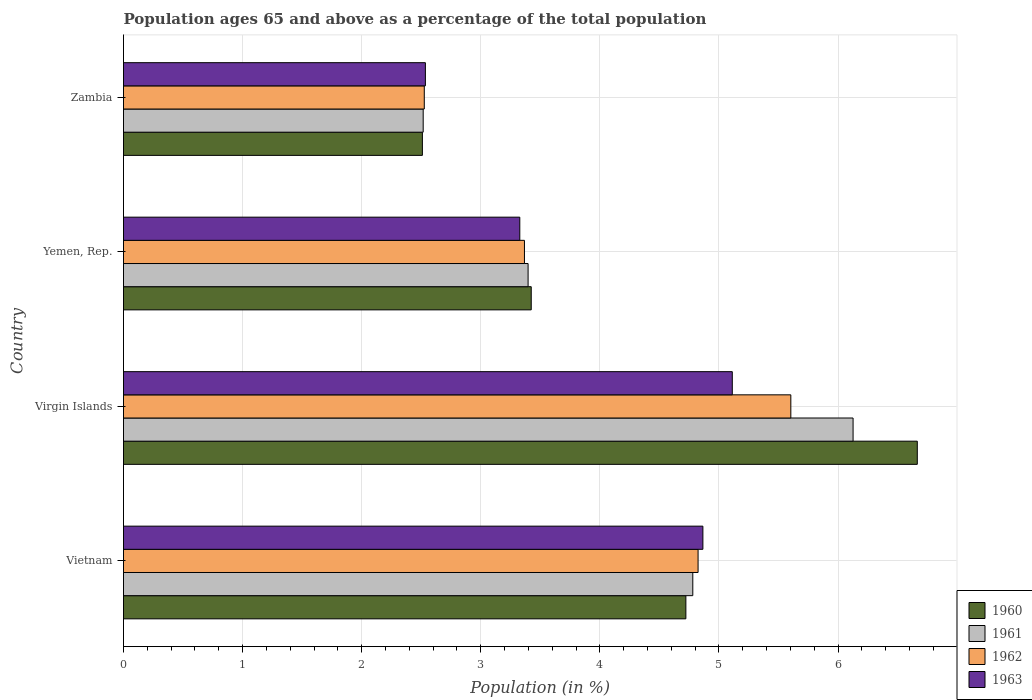How many different coloured bars are there?
Offer a very short reply. 4. Are the number of bars per tick equal to the number of legend labels?
Your answer should be compact. Yes. Are the number of bars on each tick of the Y-axis equal?
Ensure brevity in your answer.  Yes. How many bars are there on the 4th tick from the top?
Provide a short and direct response. 4. How many bars are there on the 1st tick from the bottom?
Your answer should be very brief. 4. What is the label of the 3rd group of bars from the top?
Provide a succinct answer. Virgin Islands. In how many cases, is the number of bars for a given country not equal to the number of legend labels?
Keep it short and to the point. 0. What is the percentage of the population ages 65 and above in 1961 in Virgin Islands?
Your answer should be compact. 6.13. Across all countries, what is the maximum percentage of the population ages 65 and above in 1962?
Offer a very short reply. 5.6. Across all countries, what is the minimum percentage of the population ages 65 and above in 1961?
Keep it short and to the point. 2.52. In which country was the percentage of the population ages 65 and above in 1961 maximum?
Offer a very short reply. Virgin Islands. In which country was the percentage of the population ages 65 and above in 1961 minimum?
Give a very brief answer. Zambia. What is the total percentage of the population ages 65 and above in 1961 in the graph?
Provide a short and direct response. 16.82. What is the difference between the percentage of the population ages 65 and above in 1962 in Vietnam and that in Virgin Islands?
Offer a terse response. -0.78. What is the difference between the percentage of the population ages 65 and above in 1962 in Yemen, Rep. and the percentage of the population ages 65 and above in 1961 in Vietnam?
Offer a very short reply. -1.41. What is the average percentage of the population ages 65 and above in 1960 per country?
Your response must be concise. 4.33. What is the difference between the percentage of the population ages 65 and above in 1963 and percentage of the population ages 65 and above in 1961 in Vietnam?
Keep it short and to the point. 0.08. In how many countries, is the percentage of the population ages 65 and above in 1961 greater than 1.8 ?
Keep it short and to the point. 4. What is the ratio of the percentage of the population ages 65 and above in 1960 in Virgin Islands to that in Zambia?
Give a very brief answer. 2.66. Is the percentage of the population ages 65 and above in 1960 in Virgin Islands less than that in Zambia?
Provide a succinct answer. No. Is the difference between the percentage of the population ages 65 and above in 1963 in Virgin Islands and Yemen, Rep. greater than the difference between the percentage of the population ages 65 and above in 1961 in Virgin Islands and Yemen, Rep.?
Offer a very short reply. No. What is the difference between the highest and the second highest percentage of the population ages 65 and above in 1960?
Provide a succinct answer. 1.94. What is the difference between the highest and the lowest percentage of the population ages 65 and above in 1960?
Give a very brief answer. 4.16. In how many countries, is the percentage of the population ages 65 and above in 1960 greater than the average percentage of the population ages 65 and above in 1960 taken over all countries?
Provide a succinct answer. 2. What does the 2nd bar from the top in Zambia represents?
Offer a terse response. 1962. What does the 2nd bar from the bottom in Yemen, Rep. represents?
Your answer should be compact. 1961. How many countries are there in the graph?
Your answer should be compact. 4. What is the difference between two consecutive major ticks on the X-axis?
Your answer should be compact. 1. Are the values on the major ticks of X-axis written in scientific E-notation?
Your response must be concise. No. Where does the legend appear in the graph?
Make the answer very short. Bottom right. How many legend labels are there?
Ensure brevity in your answer.  4. What is the title of the graph?
Offer a terse response. Population ages 65 and above as a percentage of the total population. Does "1967" appear as one of the legend labels in the graph?
Offer a terse response. No. What is the label or title of the X-axis?
Make the answer very short. Population (in %). What is the Population (in %) of 1960 in Vietnam?
Offer a terse response. 4.72. What is the Population (in %) in 1961 in Vietnam?
Your answer should be very brief. 4.78. What is the Population (in %) in 1962 in Vietnam?
Provide a succinct answer. 4.82. What is the Population (in %) in 1963 in Vietnam?
Give a very brief answer. 4.86. What is the Population (in %) of 1960 in Virgin Islands?
Offer a very short reply. 6.67. What is the Population (in %) in 1961 in Virgin Islands?
Give a very brief answer. 6.13. What is the Population (in %) of 1962 in Virgin Islands?
Provide a succinct answer. 5.6. What is the Population (in %) of 1963 in Virgin Islands?
Your answer should be very brief. 5.11. What is the Population (in %) of 1960 in Yemen, Rep.?
Provide a short and direct response. 3.42. What is the Population (in %) of 1961 in Yemen, Rep.?
Ensure brevity in your answer.  3.4. What is the Population (in %) in 1962 in Yemen, Rep.?
Provide a short and direct response. 3.37. What is the Population (in %) of 1963 in Yemen, Rep.?
Your answer should be compact. 3.33. What is the Population (in %) in 1960 in Zambia?
Your answer should be compact. 2.51. What is the Population (in %) in 1961 in Zambia?
Keep it short and to the point. 2.52. What is the Population (in %) in 1962 in Zambia?
Your response must be concise. 2.53. What is the Population (in %) of 1963 in Zambia?
Your answer should be very brief. 2.53. Across all countries, what is the maximum Population (in %) in 1960?
Offer a very short reply. 6.67. Across all countries, what is the maximum Population (in %) in 1961?
Keep it short and to the point. 6.13. Across all countries, what is the maximum Population (in %) of 1962?
Provide a succinct answer. 5.6. Across all countries, what is the maximum Population (in %) in 1963?
Your answer should be compact. 5.11. Across all countries, what is the minimum Population (in %) in 1960?
Your answer should be compact. 2.51. Across all countries, what is the minimum Population (in %) of 1961?
Your response must be concise. 2.52. Across all countries, what is the minimum Population (in %) of 1962?
Offer a terse response. 2.53. Across all countries, what is the minimum Population (in %) of 1963?
Offer a terse response. 2.53. What is the total Population (in %) in 1960 in the graph?
Your answer should be compact. 17.32. What is the total Population (in %) of 1961 in the graph?
Your answer should be very brief. 16.82. What is the total Population (in %) of 1962 in the graph?
Offer a terse response. 16.32. What is the total Population (in %) in 1963 in the graph?
Keep it short and to the point. 15.84. What is the difference between the Population (in %) in 1960 in Vietnam and that in Virgin Islands?
Offer a very short reply. -1.94. What is the difference between the Population (in %) of 1961 in Vietnam and that in Virgin Islands?
Your answer should be compact. -1.35. What is the difference between the Population (in %) of 1962 in Vietnam and that in Virgin Islands?
Ensure brevity in your answer.  -0.78. What is the difference between the Population (in %) in 1963 in Vietnam and that in Virgin Islands?
Provide a succinct answer. -0.25. What is the difference between the Population (in %) of 1960 in Vietnam and that in Yemen, Rep.?
Provide a succinct answer. 1.3. What is the difference between the Population (in %) of 1961 in Vietnam and that in Yemen, Rep.?
Make the answer very short. 1.38. What is the difference between the Population (in %) in 1962 in Vietnam and that in Yemen, Rep.?
Your answer should be compact. 1.46. What is the difference between the Population (in %) of 1963 in Vietnam and that in Yemen, Rep.?
Your response must be concise. 1.54. What is the difference between the Population (in %) in 1960 in Vietnam and that in Zambia?
Give a very brief answer. 2.21. What is the difference between the Population (in %) of 1961 in Vietnam and that in Zambia?
Provide a succinct answer. 2.26. What is the difference between the Population (in %) of 1962 in Vietnam and that in Zambia?
Offer a very short reply. 2.3. What is the difference between the Population (in %) in 1963 in Vietnam and that in Zambia?
Offer a very short reply. 2.33. What is the difference between the Population (in %) of 1960 in Virgin Islands and that in Yemen, Rep.?
Make the answer very short. 3.24. What is the difference between the Population (in %) of 1961 in Virgin Islands and that in Yemen, Rep.?
Your answer should be compact. 2.73. What is the difference between the Population (in %) in 1962 in Virgin Islands and that in Yemen, Rep.?
Your response must be concise. 2.24. What is the difference between the Population (in %) in 1963 in Virgin Islands and that in Yemen, Rep.?
Your response must be concise. 1.78. What is the difference between the Population (in %) in 1960 in Virgin Islands and that in Zambia?
Keep it short and to the point. 4.16. What is the difference between the Population (in %) in 1961 in Virgin Islands and that in Zambia?
Offer a terse response. 3.61. What is the difference between the Population (in %) in 1962 in Virgin Islands and that in Zambia?
Your answer should be very brief. 3.08. What is the difference between the Population (in %) of 1963 in Virgin Islands and that in Zambia?
Provide a succinct answer. 2.58. What is the difference between the Population (in %) in 1960 in Yemen, Rep. and that in Zambia?
Make the answer very short. 0.91. What is the difference between the Population (in %) in 1961 in Yemen, Rep. and that in Zambia?
Provide a short and direct response. 0.88. What is the difference between the Population (in %) of 1962 in Yemen, Rep. and that in Zambia?
Keep it short and to the point. 0.84. What is the difference between the Population (in %) in 1963 in Yemen, Rep. and that in Zambia?
Give a very brief answer. 0.79. What is the difference between the Population (in %) in 1960 in Vietnam and the Population (in %) in 1961 in Virgin Islands?
Offer a terse response. -1.4. What is the difference between the Population (in %) in 1960 in Vietnam and the Population (in %) in 1962 in Virgin Islands?
Ensure brevity in your answer.  -0.88. What is the difference between the Population (in %) of 1960 in Vietnam and the Population (in %) of 1963 in Virgin Islands?
Give a very brief answer. -0.39. What is the difference between the Population (in %) in 1961 in Vietnam and the Population (in %) in 1962 in Virgin Islands?
Offer a terse response. -0.82. What is the difference between the Population (in %) of 1961 in Vietnam and the Population (in %) of 1963 in Virgin Islands?
Offer a terse response. -0.33. What is the difference between the Population (in %) in 1962 in Vietnam and the Population (in %) in 1963 in Virgin Islands?
Keep it short and to the point. -0.29. What is the difference between the Population (in %) in 1960 in Vietnam and the Population (in %) in 1961 in Yemen, Rep.?
Your answer should be compact. 1.32. What is the difference between the Population (in %) of 1960 in Vietnam and the Population (in %) of 1962 in Yemen, Rep.?
Provide a succinct answer. 1.36. What is the difference between the Population (in %) in 1960 in Vietnam and the Population (in %) in 1963 in Yemen, Rep.?
Make the answer very short. 1.39. What is the difference between the Population (in %) of 1961 in Vietnam and the Population (in %) of 1962 in Yemen, Rep.?
Give a very brief answer. 1.41. What is the difference between the Population (in %) in 1961 in Vietnam and the Population (in %) in 1963 in Yemen, Rep.?
Keep it short and to the point. 1.45. What is the difference between the Population (in %) of 1962 in Vietnam and the Population (in %) of 1963 in Yemen, Rep.?
Offer a terse response. 1.5. What is the difference between the Population (in %) of 1960 in Vietnam and the Population (in %) of 1961 in Zambia?
Provide a succinct answer. 2.21. What is the difference between the Population (in %) in 1960 in Vietnam and the Population (in %) in 1962 in Zambia?
Give a very brief answer. 2.2. What is the difference between the Population (in %) in 1960 in Vietnam and the Population (in %) in 1963 in Zambia?
Your answer should be compact. 2.19. What is the difference between the Population (in %) in 1961 in Vietnam and the Population (in %) in 1962 in Zambia?
Offer a very short reply. 2.25. What is the difference between the Population (in %) in 1961 in Vietnam and the Population (in %) in 1963 in Zambia?
Make the answer very short. 2.25. What is the difference between the Population (in %) of 1962 in Vietnam and the Population (in %) of 1963 in Zambia?
Offer a very short reply. 2.29. What is the difference between the Population (in %) of 1960 in Virgin Islands and the Population (in %) of 1961 in Yemen, Rep.?
Make the answer very short. 3.27. What is the difference between the Population (in %) in 1960 in Virgin Islands and the Population (in %) in 1962 in Yemen, Rep.?
Your response must be concise. 3.3. What is the difference between the Population (in %) of 1960 in Virgin Islands and the Population (in %) of 1963 in Yemen, Rep.?
Offer a very short reply. 3.34. What is the difference between the Population (in %) of 1961 in Virgin Islands and the Population (in %) of 1962 in Yemen, Rep.?
Offer a very short reply. 2.76. What is the difference between the Population (in %) in 1961 in Virgin Islands and the Population (in %) in 1963 in Yemen, Rep.?
Provide a succinct answer. 2.8. What is the difference between the Population (in %) of 1962 in Virgin Islands and the Population (in %) of 1963 in Yemen, Rep.?
Give a very brief answer. 2.28. What is the difference between the Population (in %) in 1960 in Virgin Islands and the Population (in %) in 1961 in Zambia?
Your response must be concise. 4.15. What is the difference between the Population (in %) of 1960 in Virgin Islands and the Population (in %) of 1962 in Zambia?
Your response must be concise. 4.14. What is the difference between the Population (in %) of 1960 in Virgin Islands and the Population (in %) of 1963 in Zambia?
Your answer should be compact. 4.13. What is the difference between the Population (in %) of 1961 in Virgin Islands and the Population (in %) of 1962 in Zambia?
Provide a succinct answer. 3.6. What is the difference between the Population (in %) in 1961 in Virgin Islands and the Population (in %) in 1963 in Zambia?
Make the answer very short. 3.59. What is the difference between the Population (in %) in 1962 in Virgin Islands and the Population (in %) in 1963 in Zambia?
Make the answer very short. 3.07. What is the difference between the Population (in %) of 1960 in Yemen, Rep. and the Population (in %) of 1961 in Zambia?
Offer a very short reply. 0.91. What is the difference between the Population (in %) of 1960 in Yemen, Rep. and the Population (in %) of 1962 in Zambia?
Give a very brief answer. 0.9. What is the difference between the Population (in %) in 1960 in Yemen, Rep. and the Population (in %) in 1963 in Zambia?
Give a very brief answer. 0.89. What is the difference between the Population (in %) in 1961 in Yemen, Rep. and the Population (in %) in 1962 in Zambia?
Provide a succinct answer. 0.87. What is the difference between the Population (in %) of 1961 in Yemen, Rep. and the Population (in %) of 1963 in Zambia?
Provide a short and direct response. 0.86. What is the difference between the Population (in %) in 1962 in Yemen, Rep. and the Population (in %) in 1963 in Zambia?
Offer a very short reply. 0.83. What is the average Population (in %) in 1960 per country?
Give a very brief answer. 4.33. What is the average Population (in %) in 1961 per country?
Your answer should be compact. 4.2. What is the average Population (in %) of 1962 per country?
Ensure brevity in your answer.  4.08. What is the average Population (in %) of 1963 per country?
Offer a very short reply. 3.96. What is the difference between the Population (in %) in 1960 and Population (in %) in 1961 in Vietnam?
Provide a short and direct response. -0.06. What is the difference between the Population (in %) in 1960 and Population (in %) in 1962 in Vietnam?
Your answer should be very brief. -0.1. What is the difference between the Population (in %) in 1960 and Population (in %) in 1963 in Vietnam?
Make the answer very short. -0.14. What is the difference between the Population (in %) of 1961 and Population (in %) of 1962 in Vietnam?
Give a very brief answer. -0.04. What is the difference between the Population (in %) in 1961 and Population (in %) in 1963 in Vietnam?
Provide a short and direct response. -0.08. What is the difference between the Population (in %) of 1962 and Population (in %) of 1963 in Vietnam?
Your response must be concise. -0.04. What is the difference between the Population (in %) of 1960 and Population (in %) of 1961 in Virgin Islands?
Your response must be concise. 0.54. What is the difference between the Population (in %) of 1960 and Population (in %) of 1962 in Virgin Islands?
Give a very brief answer. 1.06. What is the difference between the Population (in %) in 1960 and Population (in %) in 1963 in Virgin Islands?
Offer a very short reply. 1.55. What is the difference between the Population (in %) in 1961 and Population (in %) in 1962 in Virgin Islands?
Ensure brevity in your answer.  0.52. What is the difference between the Population (in %) of 1961 and Population (in %) of 1963 in Virgin Islands?
Your answer should be compact. 1.01. What is the difference between the Population (in %) in 1962 and Population (in %) in 1963 in Virgin Islands?
Your answer should be very brief. 0.49. What is the difference between the Population (in %) in 1960 and Population (in %) in 1961 in Yemen, Rep.?
Keep it short and to the point. 0.03. What is the difference between the Population (in %) of 1960 and Population (in %) of 1962 in Yemen, Rep.?
Offer a very short reply. 0.06. What is the difference between the Population (in %) of 1960 and Population (in %) of 1963 in Yemen, Rep.?
Provide a short and direct response. 0.1. What is the difference between the Population (in %) of 1961 and Population (in %) of 1962 in Yemen, Rep.?
Make the answer very short. 0.03. What is the difference between the Population (in %) of 1961 and Population (in %) of 1963 in Yemen, Rep.?
Provide a succinct answer. 0.07. What is the difference between the Population (in %) of 1962 and Population (in %) of 1963 in Yemen, Rep.?
Give a very brief answer. 0.04. What is the difference between the Population (in %) in 1960 and Population (in %) in 1961 in Zambia?
Your answer should be compact. -0.01. What is the difference between the Population (in %) in 1960 and Population (in %) in 1962 in Zambia?
Ensure brevity in your answer.  -0.02. What is the difference between the Population (in %) in 1960 and Population (in %) in 1963 in Zambia?
Provide a succinct answer. -0.03. What is the difference between the Population (in %) in 1961 and Population (in %) in 1962 in Zambia?
Keep it short and to the point. -0.01. What is the difference between the Population (in %) of 1961 and Population (in %) of 1963 in Zambia?
Give a very brief answer. -0.02. What is the difference between the Population (in %) in 1962 and Population (in %) in 1963 in Zambia?
Give a very brief answer. -0.01. What is the ratio of the Population (in %) of 1960 in Vietnam to that in Virgin Islands?
Your response must be concise. 0.71. What is the ratio of the Population (in %) of 1961 in Vietnam to that in Virgin Islands?
Offer a terse response. 0.78. What is the ratio of the Population (in %) of 1962 in Vietnam to that in Virgin Islands?
Make the answer very short. 0.86. What is the ratio of the Population (in %) in 1963 in Vietnam to that in Virgin Islands?
Ensure brevity in your answer.  0.95. What is the ratio of the Population (in %) in 1960 in Vietnam to that in Yemen, Rep.?
Your response must be concise. 1.38. What is the ratio of the Population (in %) in 1961 in Vietnam to that in Yemen, Rep.?
Provide a succinct answer. 1.41. What is the ratio of the Population (in %) in 1962 in Vietnam to that in Yemen, Rep.?
Your response must be concise. 1.43. What is the ratio of the Population (in %) in 1963 in Vietnam to that in Yemen, Rep.?
Offer a very short reply. 1.46. What is the ratio of the Population (in %) in 1960 in Vietnam to that in Zambia?
Provide a succinct answer. 1.88. What is the ratio of the Population (in %) in 1961 in Vietnam to that in Zambia?
Ensure brevity in your answer.  1.9. What is the ratio of the Population (in %) of 1962 in Vietnam to that in Zambia?
Your answer should be compact. 1.91. What is the ratio of the Population (in %) in 1963 in Vietnam to that in Zambia?
Make the answer very short. 1.92. What is the ratio of the Population (in %) in 1960 in Virgin Islands to that in Yemen, Rep.?
Make the answer very short. 1.95. What is the ratio of the Population (in %) in 1961 in Virgin Islands to that in Yemen, Rep.?
Provide a succinct answer. 1.8. What is the ratio of the Population (in %) in 1962 in Virgin Islands to that in Yemen, Rep.?
Offer a very short reply. 1.66. What is the ratio of the Population (in %) of 1963 in Virgin Islands to that in Yemen, Rep.?
Provide a short and direct response. 1.54. What is the ratio of the Population (in %) of 1960 in Virgin Islands to that in Zambia?
Provide a succinct answer. 2.66. What is the ratio of the Population (in %) in 1961 in Virgin Islands to that in Zambia?
Provide a short and direct response. 2.43. What is the ratio of the Population (in %) in 1962 in Virgin Islands to that in Zambia?
Provide a short and direct response. 2.22. What is the ratio of the Population (in %) of 1963 in Virgin Islands to that in Zambia?
Provide a short and direct response. 2.02. What is the ratio of the Population (in %) of 1960 in Yemen, Rep. to that in Zambia?
Provide a short and direct response. 1.36. What is the ratio of the Population (in %) in 1961 in Yemen, Rep. to that in Zambia?
Make the answer very short. 1.35. What is the ratio of the Population (in %) of 1962 in Yemen, Rep. to that in Zambia?
Offer a very short reply. 1.33. What is the ratio of the Population (in %) in 1963 in Yemen, Rep. to that in Zambia?
Provide a short and direct response. 1.31. What is the difference between the highest and the second highest Population (in %) of 1960?
Your response must be concise. 1.94. What is the difference between the highest and the second highest Population (in %) of 1961?
Make the answer very short. 1.35. What is the difference between the highest and the second highest Population (in %) of 1962?
Provide a short and direct response. 0.78. What is the difference between the highest and the second highest Population (in %) of 1963?
Offer a very short reply. 0.25. What is the difference between the highest and the lowest Population (in %) in 1960?
Provide a short and direct response. 4.16. What is the difference between the highest and the lowest Population (in %) of 1961?
Your response must be concise. 3.61. What is the difference between the highest and the lowest Population (in %) of 1962?
Ensure brevity in your answer.  3.08. What is the difference between the highest and the lowest Population (in %) of 1963?
Offer a terse response. 2.58. 